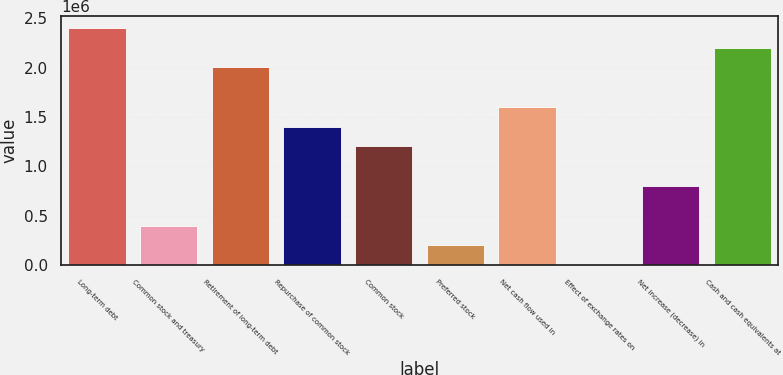Convert chart to OTSL. <chart><loc_0><loc_0><loc_500><loc_500><bar_chart><fcel>Long-term debt<fcel>Common stock and treasury<fcel>Retirement of long-term debt<fcel>Repurchase of common stock<fcel>Common stock<fcel>Preferred stock<fcel>Net cash flow used in<fcel>Effect of exchange rates on<fcel>Net increase (decrease) in<fcel>Cash and cash equivalents at<nl><fcel>2.4039e+06<fcel>401747<fcel>2.00347e+06<fcel>1.40282e+06<fcel>1.20261e+06<fcel>201531<fcel>1.60304e+06<fcel>1316<fcel>802177<fcel>2.20368e+06<nl></chart> 